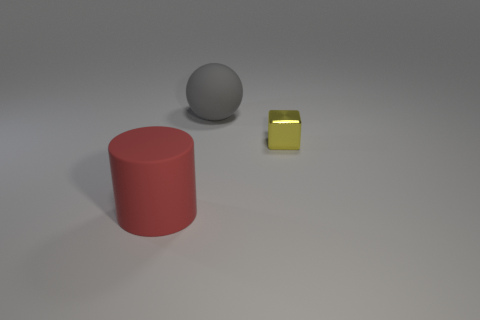Is there any other thing that is the same material as the small block?
Ensure brevity in your answer.  No. How many other objects are there of the same size as the gray matte thing?
Provide a short and direct response. 1. Do the object that is left of the large ball and the thing right of the big rubber ball have the same shape?
Your response must be concise. No. Are there an equal number of balls in front of the ball and small green matte cylinders?
Your response must be concise. Yes. What number of big red cylinders have the same material as the gray object?
Your answer should be compact. 1. There is a thing that is made of the same material as the gray ball; what is its color?
Keep it short and to the point. Red. There is a gray ball; is it the same size as the matte object to the left of the ball?
Make the answer very short. Yes. The gray matte object is what shape?
Ensure brevity in your answer.  Sphere. How many large cylinders are on the right side of the thing in front of the tiny cube?
Offer a very short reply. 0. What number of balls are gray things or yellow metal things?
Provide a short and direct response. 1. 